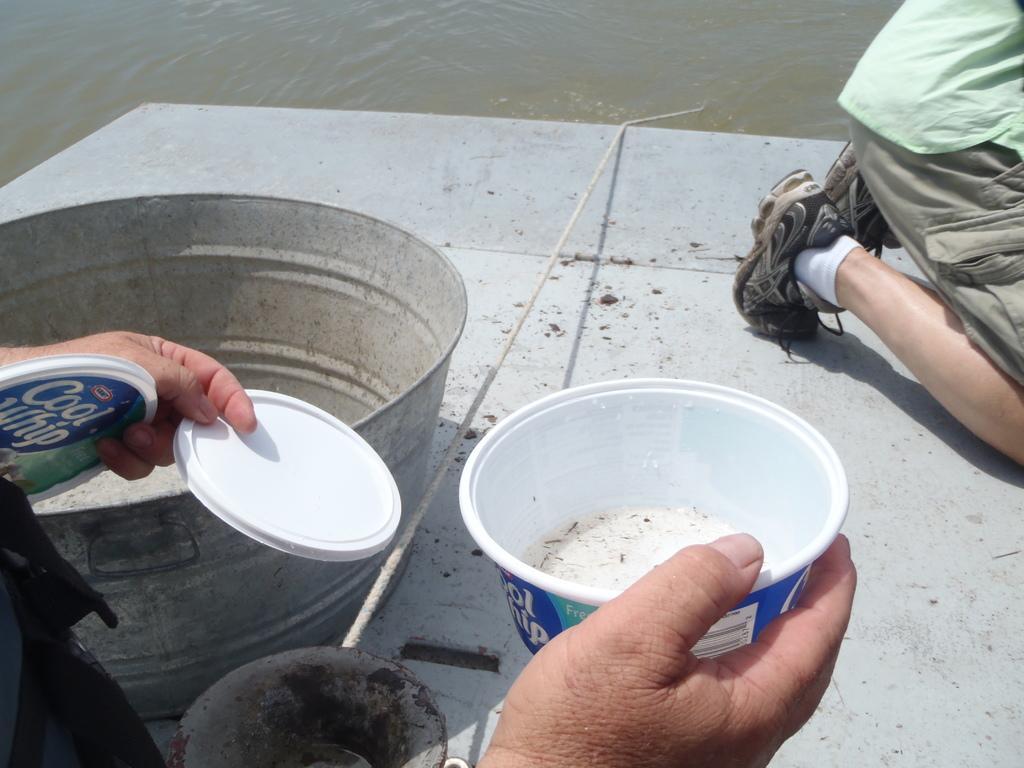Could you give a brief overview of what you see in this image? In this image I see 2 persons in which this person holding 2 cups in one hand and a plastic bowl in other hand and I see the container over here and I see the white rope and I see the white surface. In the background I see the water. 